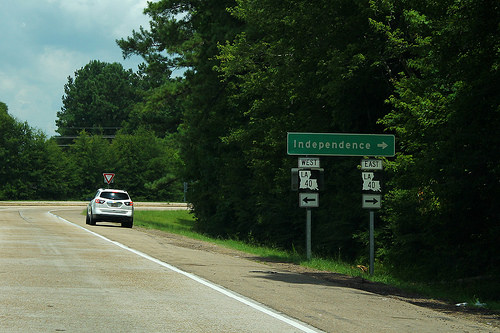<image>
Is the tree in front of the car? No. The tree is not in front of the car. The spatial positioning shows a different relationship between these objects. Is the sign above the car? No. The sign is not positioned above the car. The vertical arrangement shows a different relationship. 